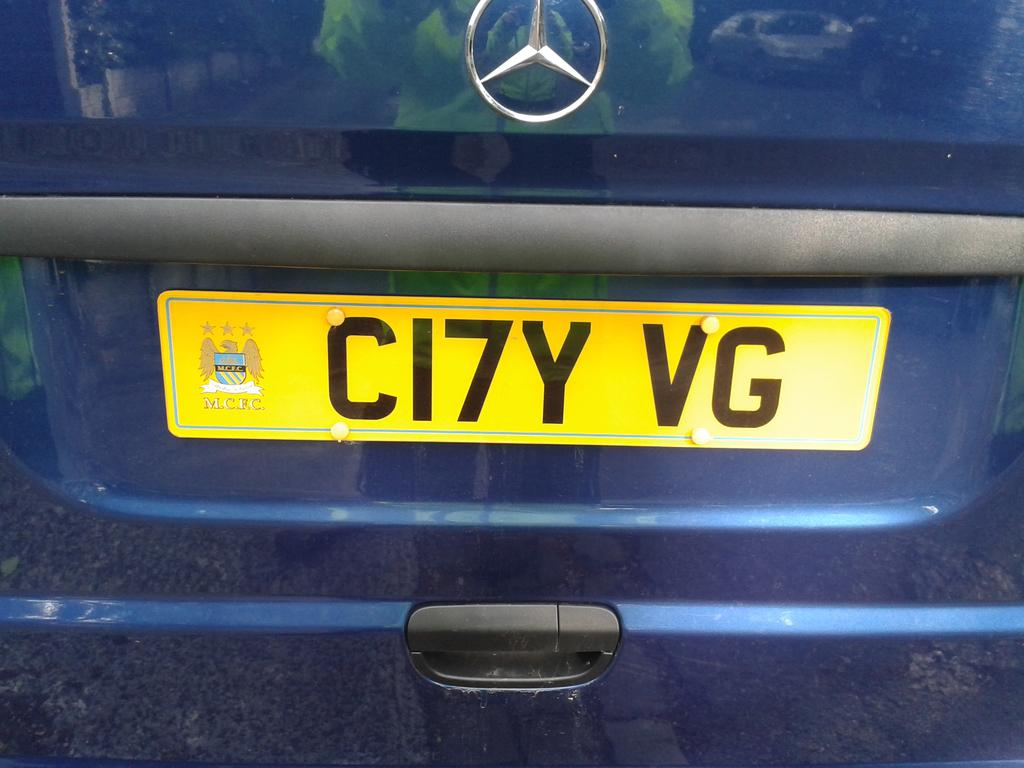<image>
Describe the image concisely. the letters CI7Y on the back of a license plate 